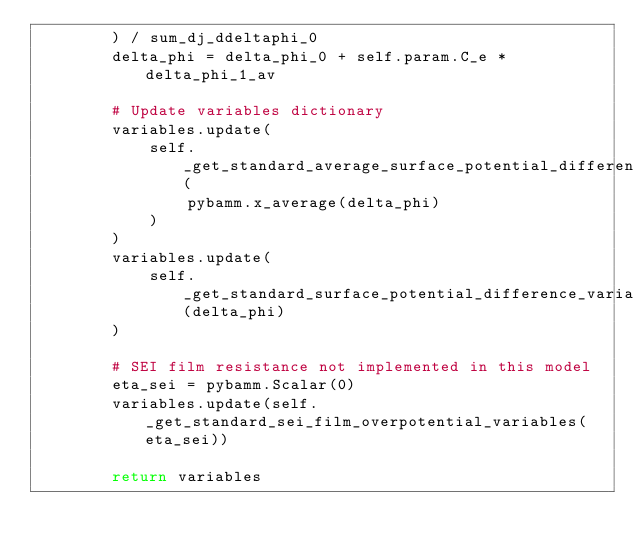Convert code to text. <code><loc_0><loc_0><loc_500><loc_500><_Python_>        ) / sum_dj_ddeltaphi_0
        delta_phi = delta_phi_0 + self.param.C_e * delta_phi_1_av

        # Update variables dictionary
        variables.update(
            self._get_standard_average_surface_potential_difference_variables(
                pybamm.x_average(delta_phi)
            )
        )
        variables.update(
            self._get_standard_surface_potential_difference_variables(delta_phi)
        )

        # SEI film resistance not implemented in this model
        eta_sei = pybamm.Scalar(0)
        variables.update(self._get_standard_sei_film_overpotential_variables(eta_sei))

        return variables
</code> 